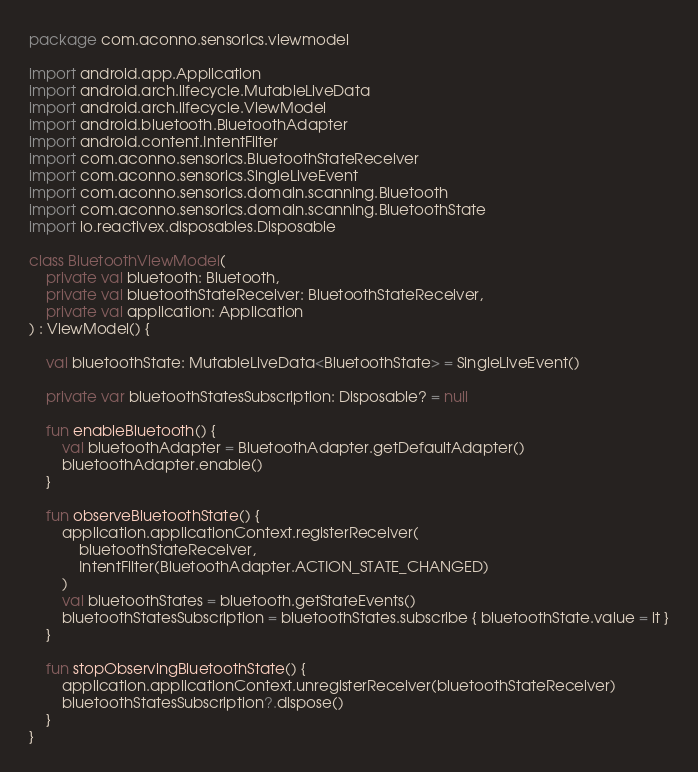<code> <loc_0><loc_0><loc_500><loc_500><_Kotlin_>package com.aconno.sensorics.viewmodel

import android.app.Application
import android.arch.lifecycle.MutableLiveData
import android.arch.lifecycle.ViewModel
import android.bluetooth.BluetoothAdapter
import android.content.IntentFilter
import com.aconno.sensorics.BluetoothStateReceiver
import com.aconno.sensorics.SingleLiveEvent
import com.aconno.sensorics.domain.scanning.Bluetooth
import com.aconno.sensorics.domain.scanning.BluetoothState
import io.reactivex.disposables.Disposable

class BluetoothViewModel(
    private val bluetooth: Bluetooth,
    private val bluetoothStateReceiver: BluetoothStateReceiver,
    private val application: Application
) : ViewModel() {

    val bluetoothState: MutableLiveData<BluetoothState> = SingleLiveEvent()

    private var bluetoothStatesSubscription: Disposable? = null

    fun enableBluetooth() {
        val bluetoothAdapter = BluetoothAdapter.getDefaultAdapter()
        bluetoothAdapter.enable()
    }

    fun observeBluetoothState() {
        application.applicationContext.registerReceiver(
            bluetoothStateReceiver,
            IntentFilter(BluetoothAdapter.ACTION_STATE_CHANGED)
        )
        val bluetoothStates = bluetooth.getStateEvents()
        bluetoothStatesSubscription = bluetoothStates.subscribe { bluetoothState.value = it }
    }

    fun stopObservingBluetoothState() {
        application.applicationContext.unregisterReceiver(bluetoothStateReceiver)
        bluetoothStatesSubscription?.dispose()
    }
}</code> 